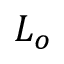<formula> <loc_0><loc_0><loc_500><loc_500>L _ { o }</formula> 